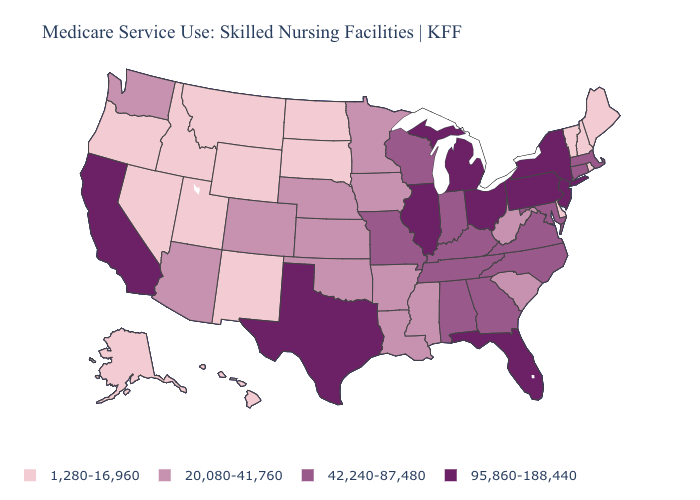What is the highest value in the Northeast ?
Answer briefly. 95,860-188,440. Name the states that have a value in the range 95,860-188,440?
Answer briefly. California, Florida, Illinois, Michigan, New Jersey, New York, Ohio, Pennsylvania, Texas. Which states hav the highest value in the MidWest?
Be succinct. Illinois, Michigan, Ohio. Among the states that border Maine , which have the lowest value?
Give a very brief answer. New Hampshire. Does Pennsylvania have the lowest value in the USA?
Short answer required. No. Does California have the highest value in the USA?
Concise answer only. Yes. Does New Mexico have the lowest value in the West?
Give a very brief answer. Yes. Name the states that have a value in the range 1,280-16,960?
Concise answer only. Alaska, Delaware, Hawaii, Idaho, Maine, Montana, Nevada, New Hampshire, New Mexico, North Dakota, Oregon, Rhode Island, South Dakota, Utah, Vermont, Wyoming. Does the map have missing data?
Keep it brief. No. Does Connecticut have the lowest value in the USA?
Quick response, please. No. Which states have the lowest value in the USA?
Concise answer only. Alaska, Delaware, Hawaii, Idaho, Maine, Montana, Nevada, New Hampshire, New Mexico, North Dakota, Oregon, Rhode Island, South Dakota, Utah, Vermont, Wyoming. Name the states that have a value in the range 95,860-188,440?
Answer briefly. California, Florida, Illinois, Michigan, New Jersey, New York, Ohio, Pennsylvania, Texas. Which states hav the highest value in the MidWest?
Write a very short answer. Illinois, Michigan, Ohio. Among the states that border Michigan , does Wisconsin have the highest value?
Quick response, please. No. What is the value of New Hampshire?
Concise answer only. 1,280-16,960. 